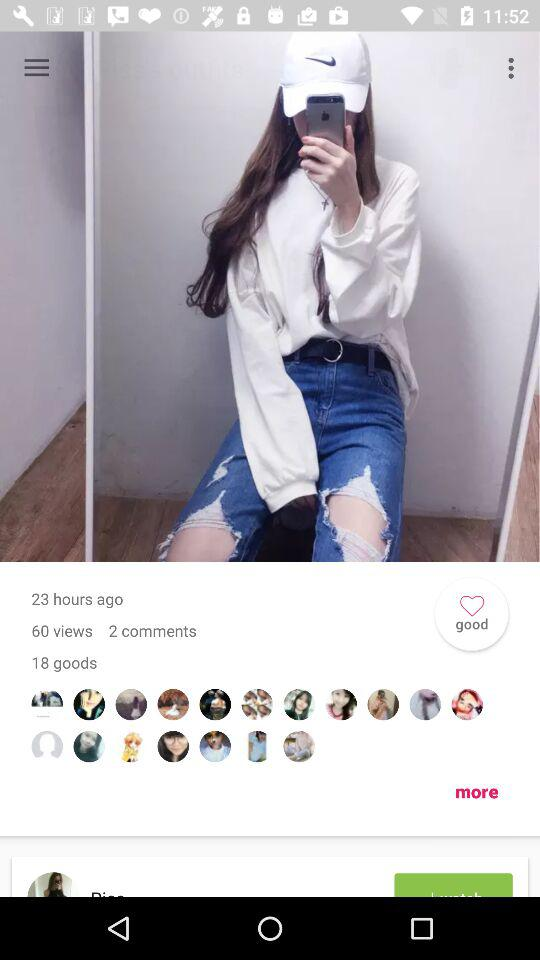How many goods are there? There are 18 goods. 